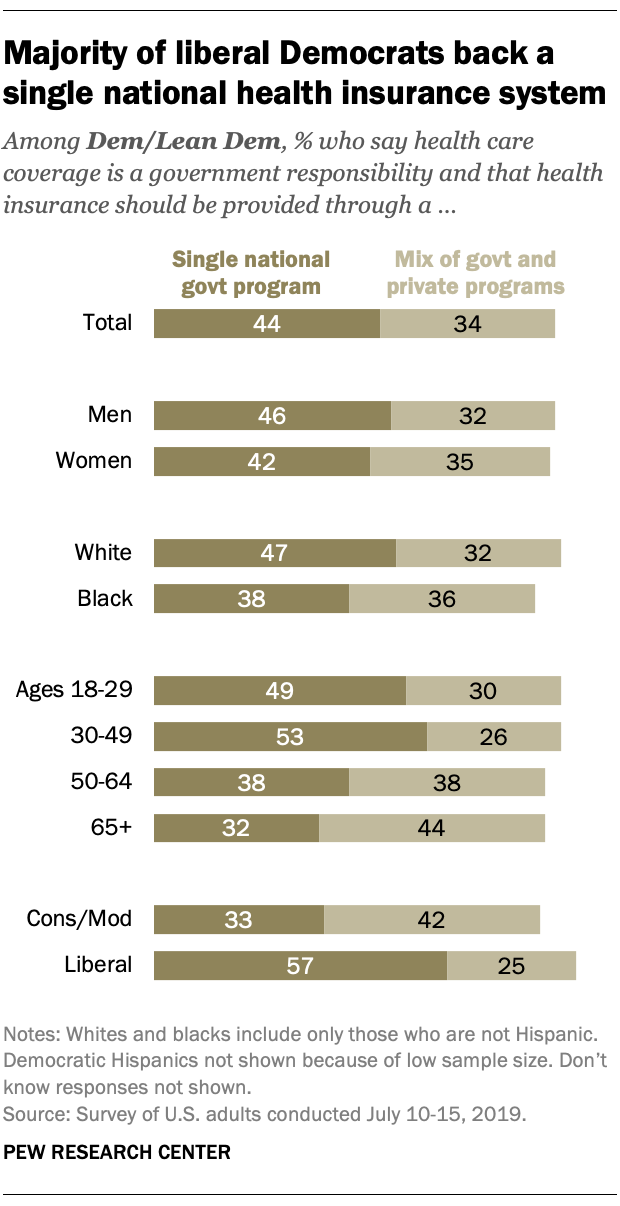Identify some key points in this picture. According to the data, a significant percentage of 8 categories prefer a single government program over a mixed one. The preference for a single national government program among people is 44%. 